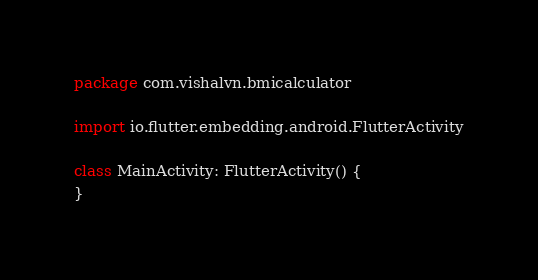<code> <loc_0><loc_0><loc_500><loc_500><_Kotlin_>package com.vishalvn.bmicalculator

import io.flutter.embedding.android.FlutterActivity

class MainActivity: FlutterActivity() {
}
</code> 